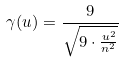Convert formula to latex. <formula><loc_0><loc_0><loc_500><loc_500>\gamma ( u ) = \frac { 9 } { \sqrt { 9 \cdot \frac { u ^ { 2 } } { n ^ { 2 } } } }</formula> 